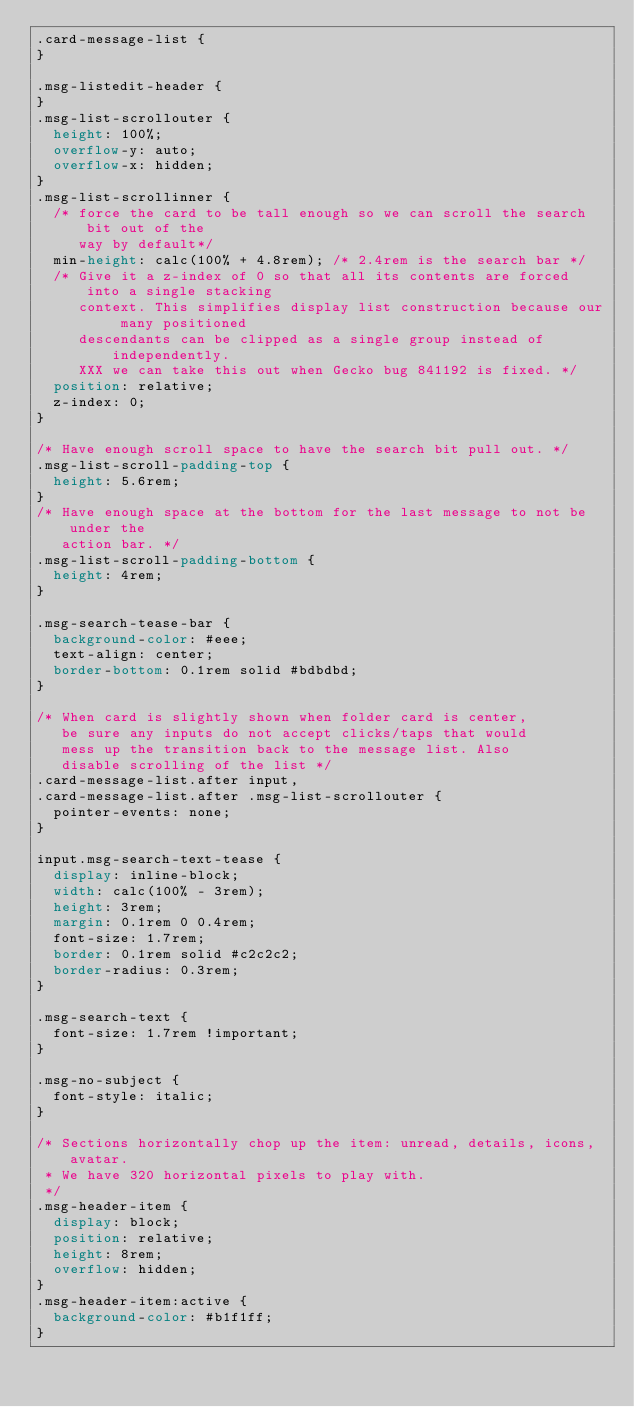<code> <loc_0><loc_0><loc_500><loc_500><_CSS_>.card-message-list {
}

.msg-listedit-header {
}
.msg-list-scrollouter {
  height: 100%;
  overflow-y: auto;
  overflow-x: hidden;
}
.msg-list-scrollinner {
  /* force the card to be tall enough so we can scroll the search bit out of the
     way by default*/
  min-height: calc(100% + 4.8rem); /* 2.4rem is the search bar */
  /* Give it a z-index of 0 so that all its contents are forced into a single stacking
     context. This simplifies display list construction because our many positioned
     descendants can be clipped as a single group instead of independently.
     XXX we can take this out when Gecko bug 841192 is fixed. */
  position: relative;
  z-index: 0;
}

/* Have enough scroll space to have the search bit pull out. */
.msg-list-scroll-padding-top {
  height: 5.6rem;
}
/* Have enough space at the bottom for the last message to not be under the
   action bar. */
.msg-list-scroll-padding-bottom {
  height: 4rem;
}

.msg-search-tease-bar {
  background-color: #eee;
  text-align: center;
  border-bottom: 0.1rem solid #bdbdbd;
}

/* When card is slightly shown when folder card is center,
   be sure any inputs do not accept clicks/taps that would
   mess up the transition back to the message list. Also
   disable scrolling of the list */
.card-message-list.after input,
.card-message-list.after .msg-list-scrollouter {
  pointer-events: none;
}

input.msg-search-text-tease {
  display: inline-block;
  width: calc(100% - 3rem);
  height: 3rem;
  margin: 0.1rem 0 0.4rem;
  font-size: 1.7rem;
  border: 0.1rem solid #c2c2c2;
  border-radius: 0.3rem;
}

.msg-search-text {
  font-size: 1.7rem !important;
}

.msg-no-subject {
  font-style: italic;
}

/* Sections horizontally chop up the item: unread, details, icons, avatar.
 * We have 320 horizontal pixels to play with.
 */
.msg-header-item {
  display: block;
  position: relative;
  height: 8rem;
  overflow: hidden;
}
.msg-header-item:active {
  background-color: #b1f1ff;
}</code> 